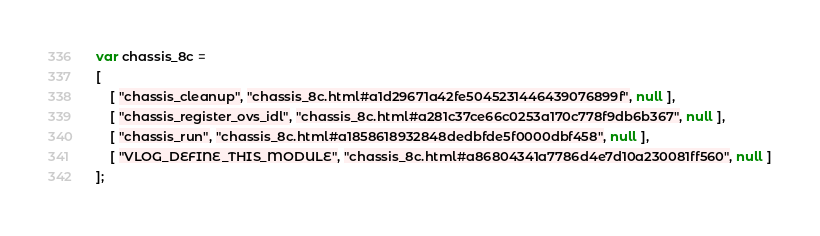Convert code to text. <code><loc_0><loc_0><loc_500><loc_500><_JavaScript_>var chassis_8c =
[
    [ "chassis_cleanup", "chassis_8c.html#a1d29671a42fe5045231446439076899f", null ],
    [ "chassis_register_ovs_idl", "chassis_8c.html#a281c37ce66c0253a170c778f9db6b367", null ],
    [ "chassis_run", "chassis_8c.html#a1858618932848dedbfde5f0000dbf458", null ],
    [ "VLOG_DEFINE_THIS_MODULE", "chassis_8c.html#a86804341a7786d4e7d10a230081ff560", null ]
];</code> 